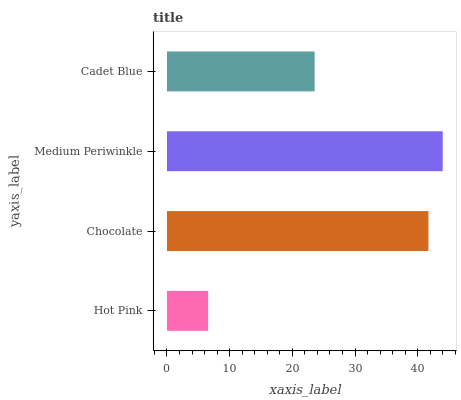Is Hot Pink the minimum?
Answer yes or no. Yes. Is Medium Periwinkle the maximum?
Answer yes or no. Yes. Is Chocolate the minimum?
Answer yes or no. No. Is Chocolate the maximum?
Answer yes or no. No. Is Chocolate greater than Hot Pink?
Answer yes or no. Yes. Is Hot Pink less than Chocolate?
Answer yes or no. Yes. Is Hot Pink greater than Chocolate?
Answer yes or no. No. Is Chocolate less than Hot Pink?
Answer yes or no. No. Is Chocolate the high median?
Answer yes or no. Yes. Is Cadet Blue the low median?
Answer yes or no. Yes. Is Hot Pink the high median?
Answer yes or no. No. Is Hot Pink the low median?
Answer yes or no. No. 